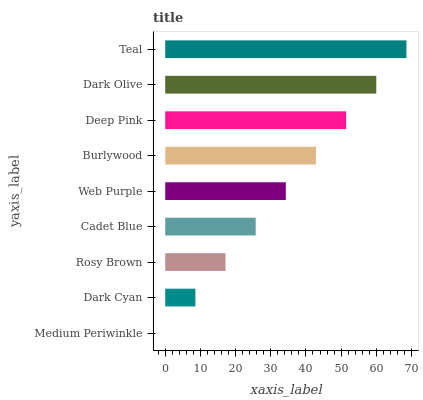Is Medium Periwinkle the minimum?
Answer yes or no. Yes. Is Teal the maximum?
Answer yes or no. Yes. Is Dark Cyan the minimum?
Answer yes or no. No. Is Dark Cyan the maximum?
Answer yes or no. No. Is Dark Cyan greater than Medium Periwinkle?
Answer yes or no. Yes. Is Medium Periwinkle less than Dark Cyan?
Answer yes or no. Yes. Is Medium Periwinkle greater than Dark Cyan?
Answer yes or no. No. Is Dark Cyan less than Medium Periwinkle?
Answer yes or no. No. Is Web Purple the high median?
Answer yes or no. Yes. Is Web Purple the low median?
Answer yes or no. Yes. Is Burlywood the high median?
Answer yes or no. No. Is Burlywood the low median?
Answer yes or no. No. 